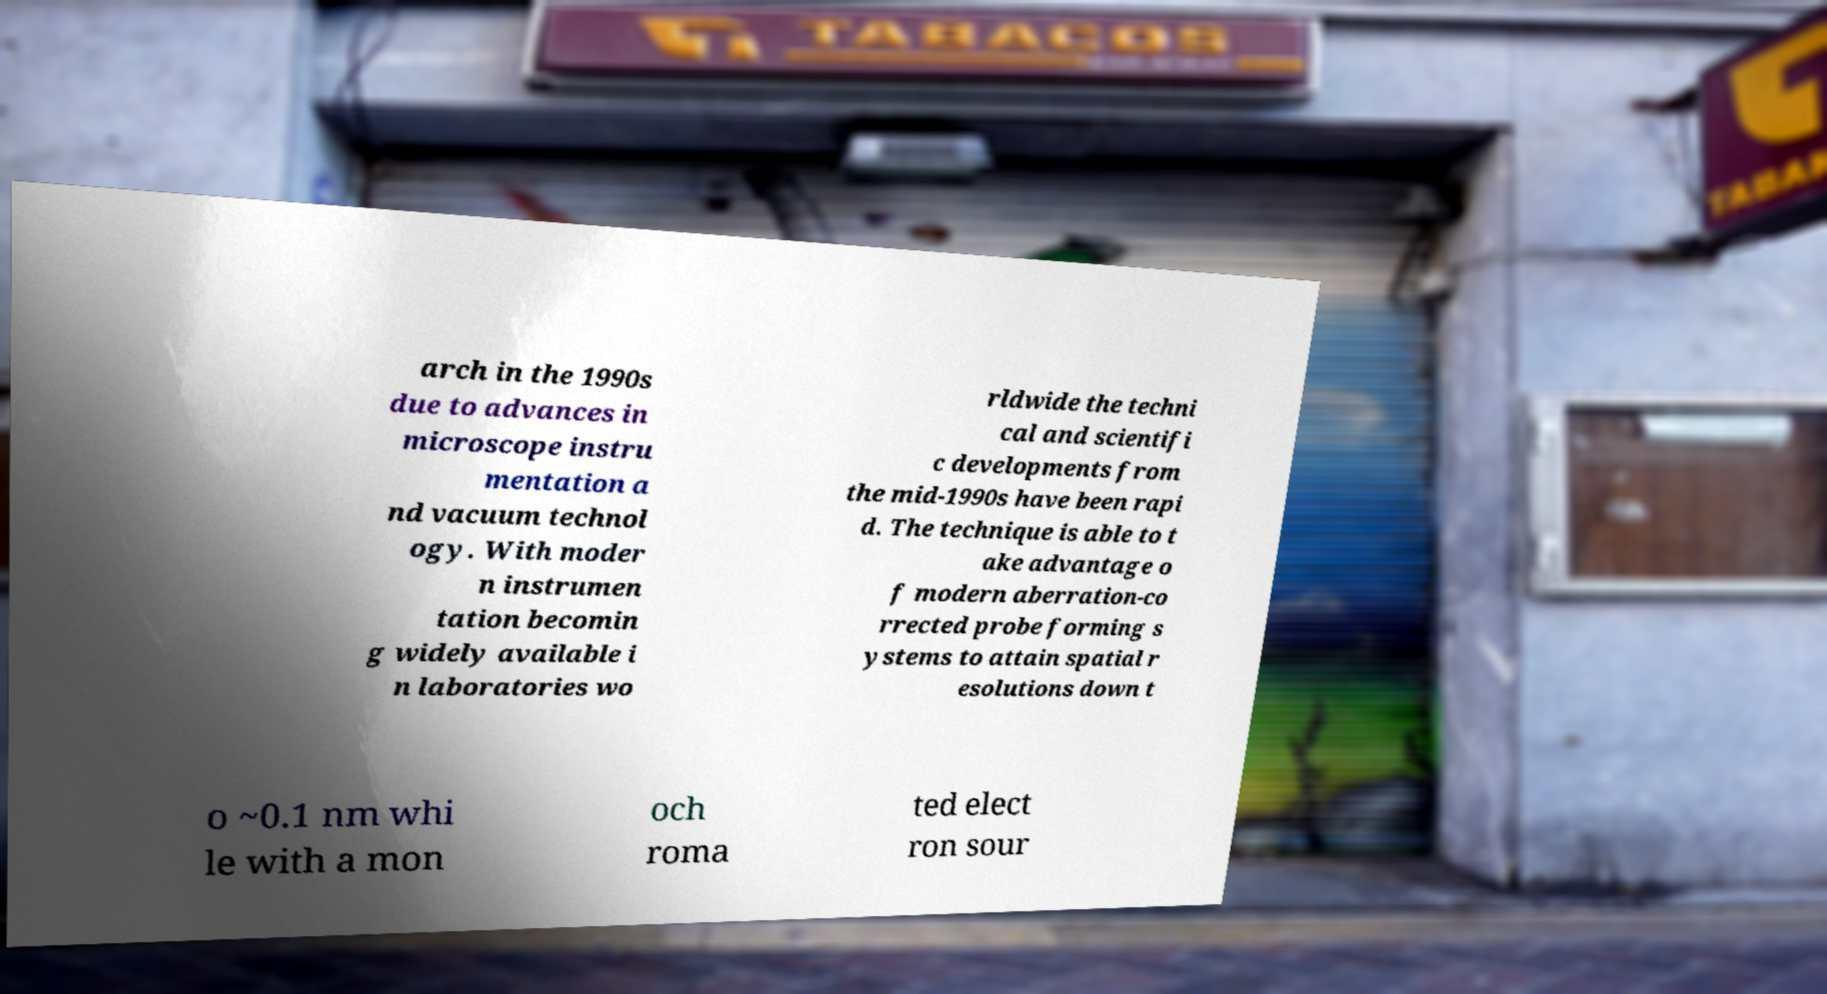There's text embedded in this image that I need extracted. Can you transcribe it verbatim? arch in the 1990s due to advances in microscope instru mentation a nd vacuum technol ogy. With moder n instrumen tation becomin g widely available i n laboratories wo rldwide the techni cal and scientifi c developments from the mid-1990s have been rapi d. The technique is able to t ake advantage o f modern aberration-co rrected probe forming s ystems to attain spatial r esolutions down t o ~0.1 nm whi le with a mon och roma ted elect ron sour 